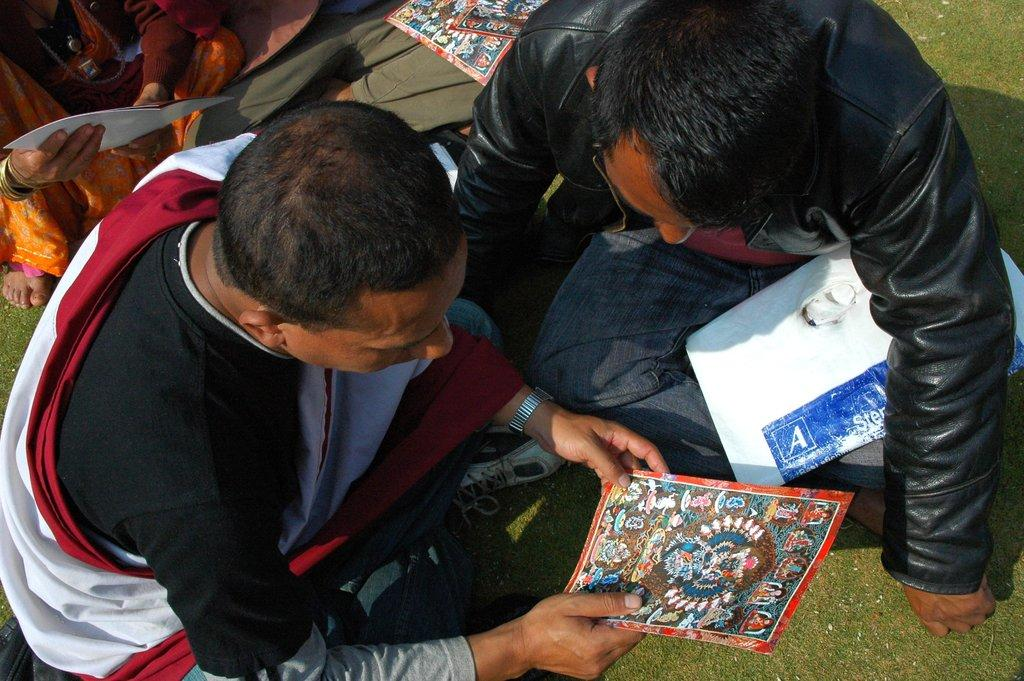What is the person in the image holding? The person in the image is holding a poster. Where is the person sitting in the image? The person is sitting on the ground. Are there any other people in the image? Yes, there are other people sitting on the ground in the image. What type of winter clothing is the person wearing in the image? There is no mention of winter clothing or any specific season in the image, so it cannot determine what type of clothing the person is wearing. 